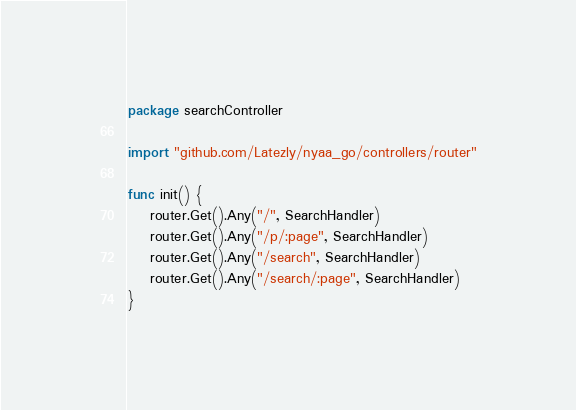Convert code to text. <code><loc_0><loc_0><loc_500><loc_500><_Go_>package searchController

import "github.com/Latezly/nyaa_go/controllers/router"

func init() {
	router.Get().Any("/", SearchHandler)
	router.Get().Any("/p/:page", SearchHandler)
	router.Get().Any("/search", SearchHandler)
	router.Get().Any("/search/:page", SearchHandler)
}
</code> 